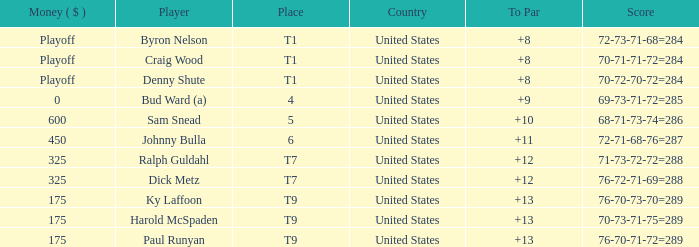Write the full table. {'header': ['Money ( $ )', 'Player', 'Place', 'Country', 'To Par', 'Score'], 'rows': [['Playoff', 'Byron Nelson', 'T1', 'United States', '+8', '72-73-71-68=284'], ['Playoff', 'Craig Wood', 'T1', 'United States', '+8', '70-71-71-72=284'], ['Playoff', 'Denny Shute', 'T1', 'United States', '+8', '70-72-70-72=284'], ['0', 'Bud Ward (a)', '4', 'United States', '+9', '69-73-71-72=285'], ['600', 'Sam Snead', '5', 'United States', '+10', '68-71-73-74=286'], ['450', 'Johnny Bulla', '6', 'United States', '+11', '72-71-68-76=287'], ['325', 'Ralph Guldahl', 'T7', 'United States', '+12', '71-73-72-72=288'], ['325', 'Dick Metz', 'T7', 'United States', '+12', '76-72-71-69=288'], ['175', 'Ky Laffoon', 'T9', 'United States', '+13', '76-70-73-70=289'], ['175', 'Harold McSpaden', 'T9', 'United States', '+13', '70-73-71-75=289'], ['175', 'Paul Runyan', 'T9', 'United States', '+13', '76-70-71-72=289']]} What was the score for t9 place for Harold Mcspaden? 70-73-71-75=289. 